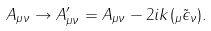Convert formula to latex. <formula><loc_0><loc_0><loc_500><loc_500>A _ { \mu \nu } \rightarrow A ^ { \prime } _ { \mu \nu } = A _ { \mu \nu } - 2 i k ( _ { \mu } \tilde { \epsilon } _ { \nu } ) .</formula> 